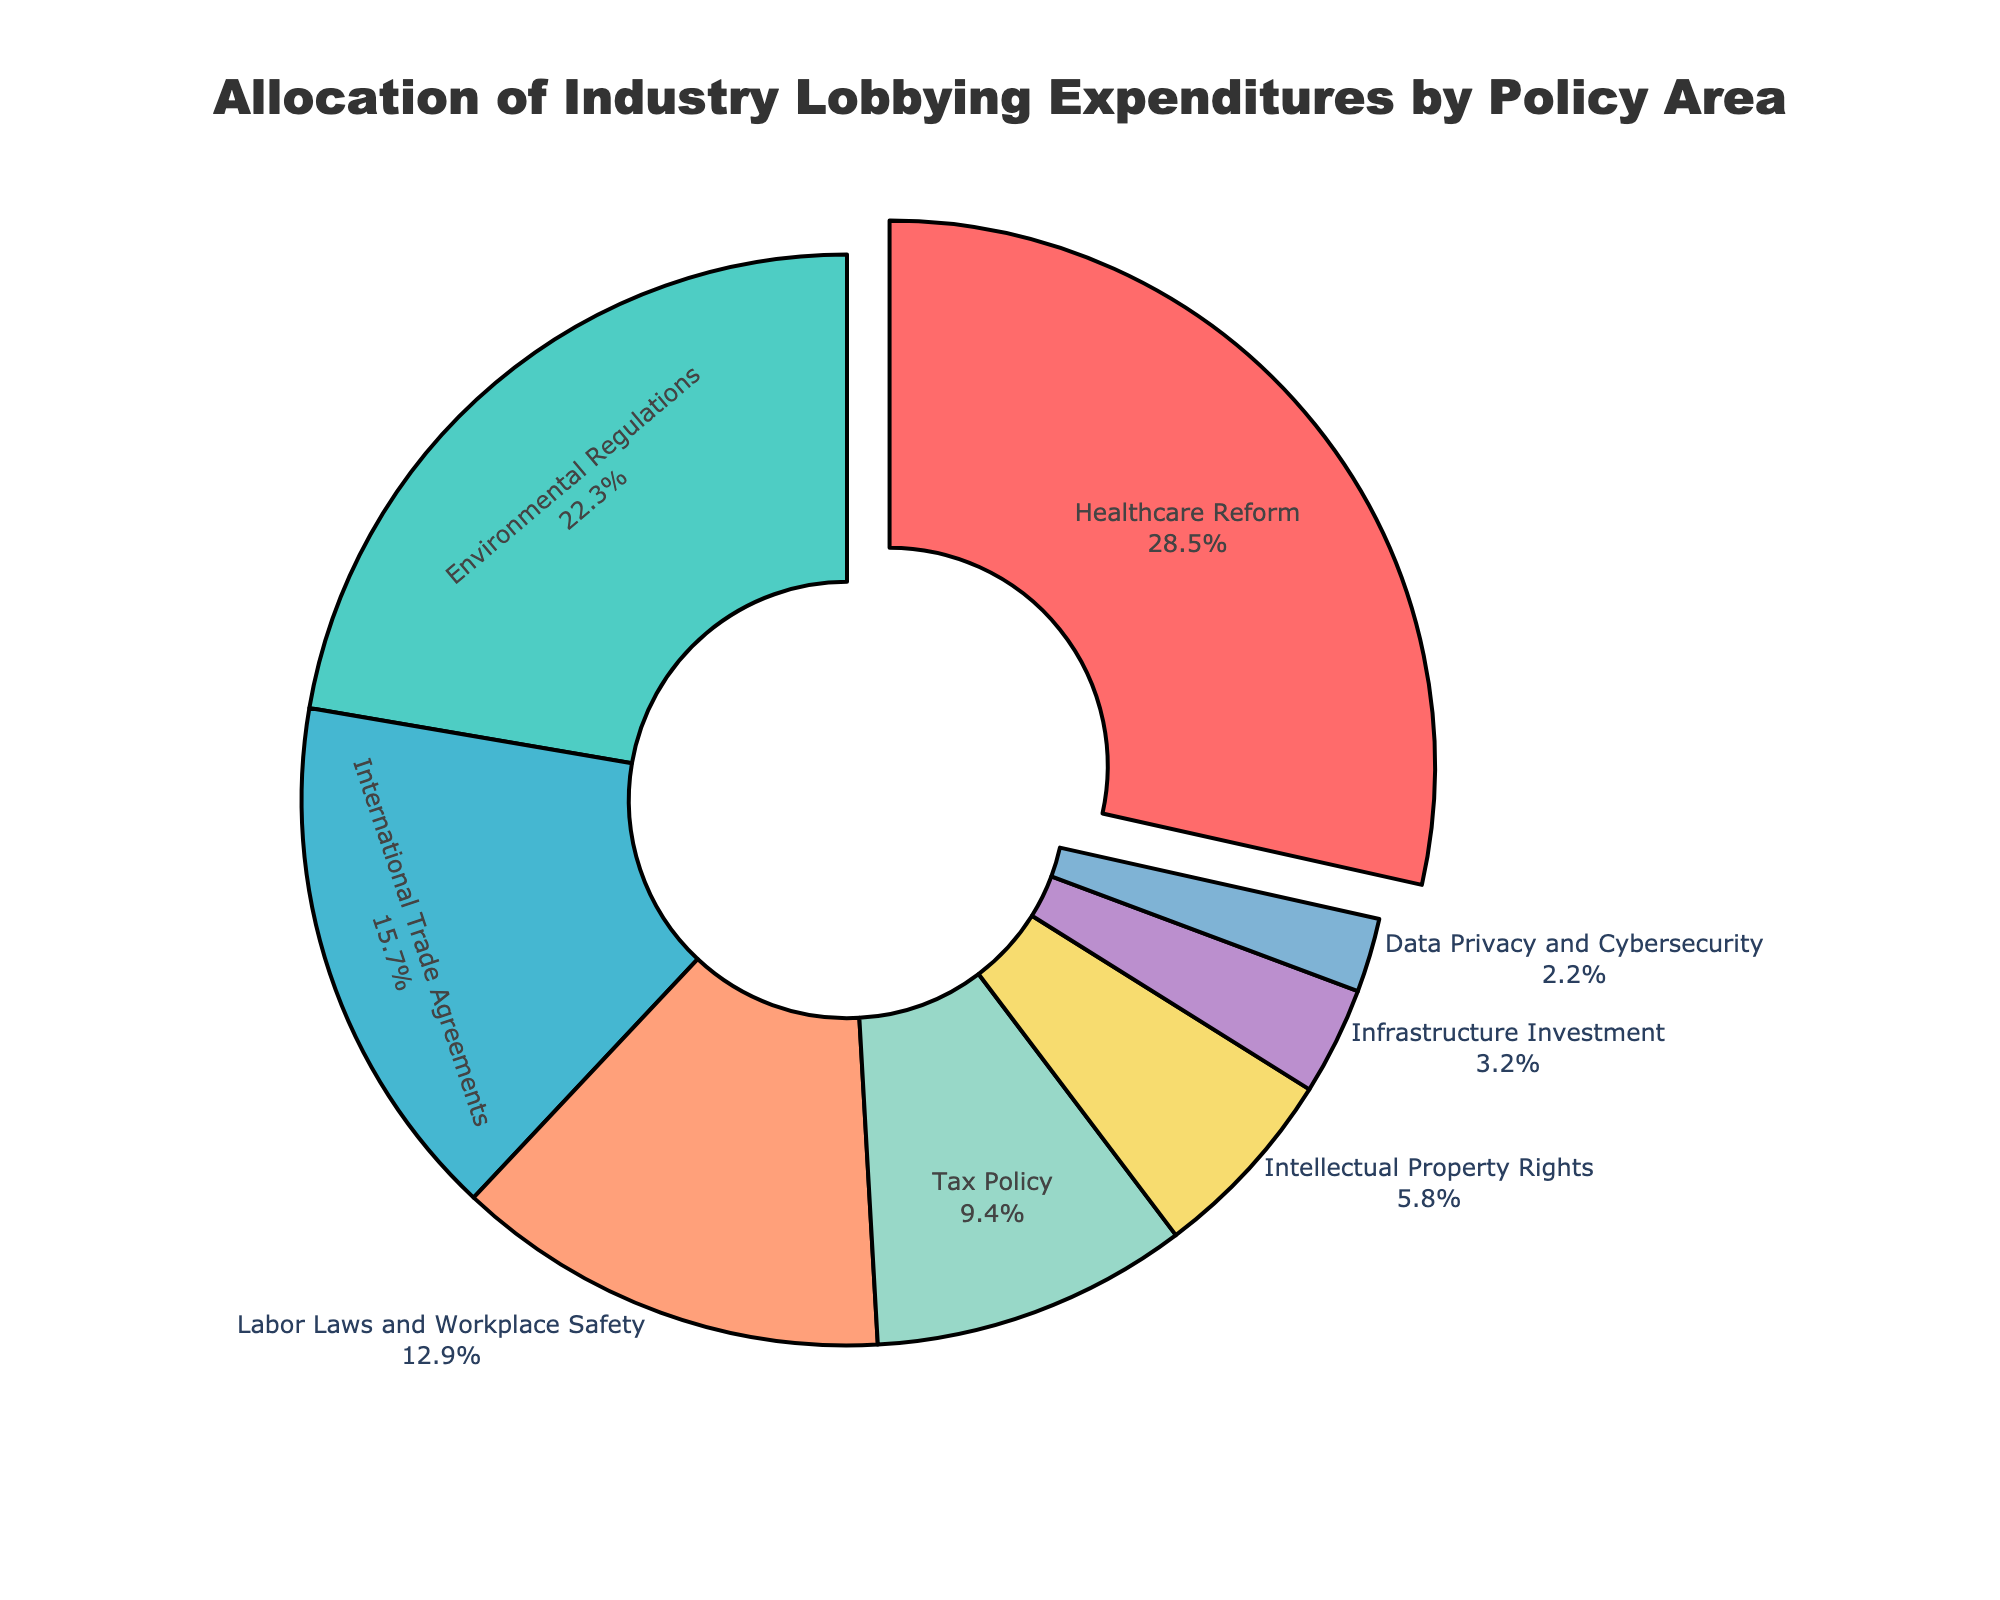What's the largest allocation percentage for a policy area? The figure shows a pie chart with segments labeled and percentages listed. The largest segment is labeled "Healthcare Reform" with an expenditure percentage of 28.5%.
Answer: Healthcare Reform Which policy area has the smallest expenditure percentage? By examining the pie chart, the smallest segment is labeled "Data Privacy and Cybersecurity" with an expenditure percentage of 2.2%.
Answer: Data Privacy and Cybersecurity What is the combined expenditure percentage for Environmental Regulations and Tax Policy? The percentages for Environmental Regulations and Tax Policy are 22.3% and 9.4%, respectively. Adding these together yields 22.3 + 9.4 = 31.7%.
Answer: 31.7% Which policy area has a higher allocation, Labor Laws and Workplace Safety or International Trade Agreements? Comparing the segments, Labor Laws and Workplace Safety has an expenditure percentage of 12.9%, while International Trade Agreements has 15.7%. 15.7% is greater than 12.9%.
Answer: International Trade Agreements What is the percentage difference between Healthcare Reform and Intellectual Property Rights? The expenditure percentage for Healthcare Reform is 28.5% and for Intellectual Property Rights it is 5.8%. The difference is 28.5 - 5.8 = 22.7%.
Answer: 22.7% Which policy area is highlighted/pulled out in the pie chart? The only section of the pie chart that appears to be pulled out is the one labeled "Healthcare Reform".
Answer: Healthcare Reform What percentage of the total allocation do Healthcare Reform, Environmental Regulations, and International Trade Agreements represent together? The expenditure percentages for Healthcare Reform, Environmental Regulations, and International Trade Agreements are 28.5%, 22.3%, and 15.7%, respectively. Summing these gives 28.5 + 22.3 + 15.7 = 66.5%.
Answer: 66.5% Does Tax Policy have a higher or lower expenditure allocation than Infrastructure Investment? Tax Policy has an expenditure percentage of 9.4%, while Infrastructure Investment has an expenditure percentage of 3.2%. 9.4% is greater than 3.2%.
Answer: Higher 